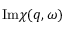<formula> <loc_0><loc_0><loc_500><loc_500>I m \chi ( q , \omega )</formula> 